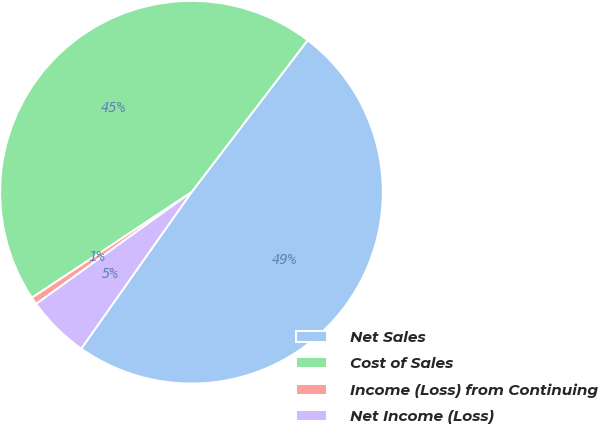Convert chart to OTSL. <chart><loc_0><loc_0><loc_500><loc_500><pie_chart><fcel>Net Sales<fcel>Cost of Sales<fcel>Income (Loss) from Continuing<fcel>Net Income (Loss)<nl><fcel>49.38%<fcel>44.69%<fcel>0.62%<fcel>5.31%<nl></chart> 